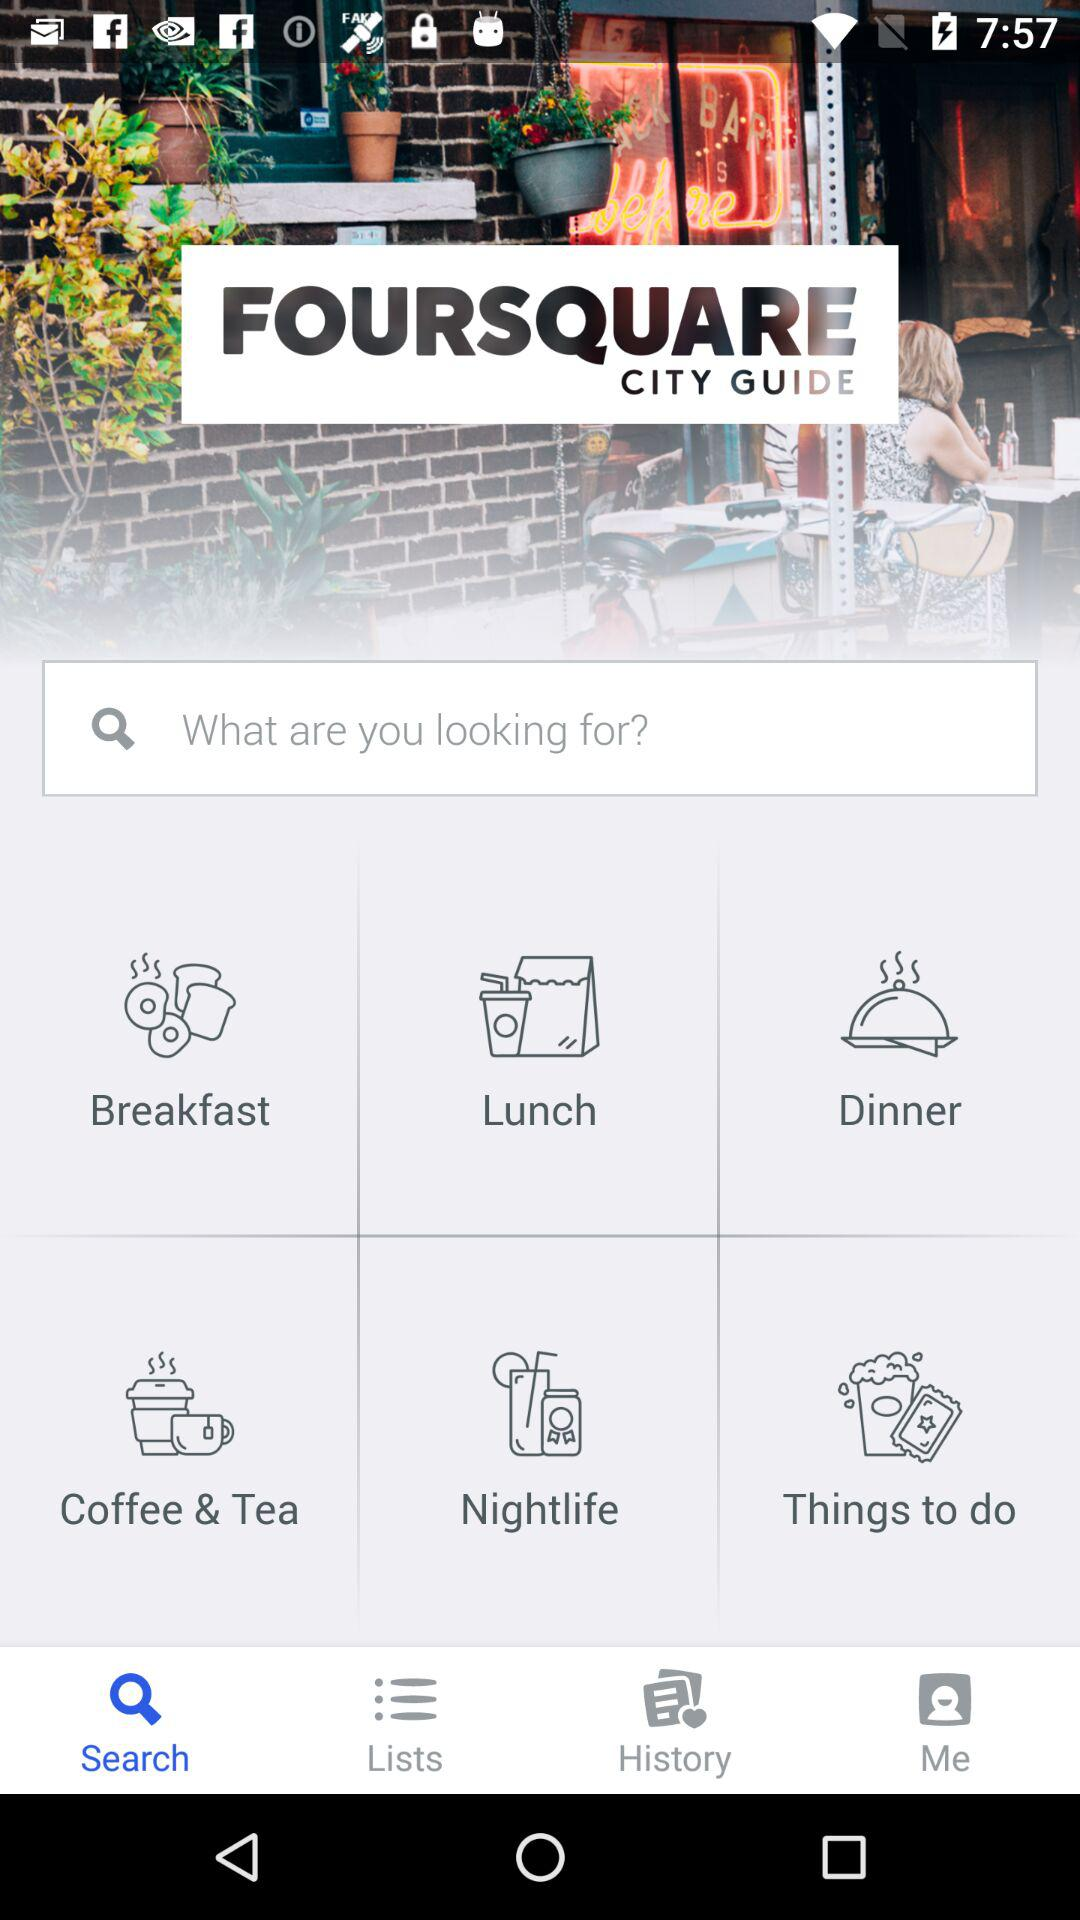Which tab is open? The open tab is "Search". 